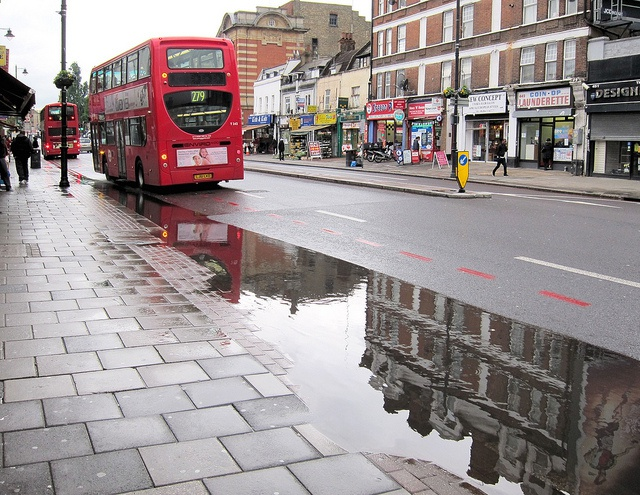Describe the objects in this image and their specific colors. I can see bus in darkgray, black, brown, and maroon tones, bus in darkgray, black, maroon, brown, and gray tones, people in darkgray, black, and gray tones, people in darkgray, black, gray, maroon, and lightgray tones, and people in darkgray, black, and gray tones in this image. 